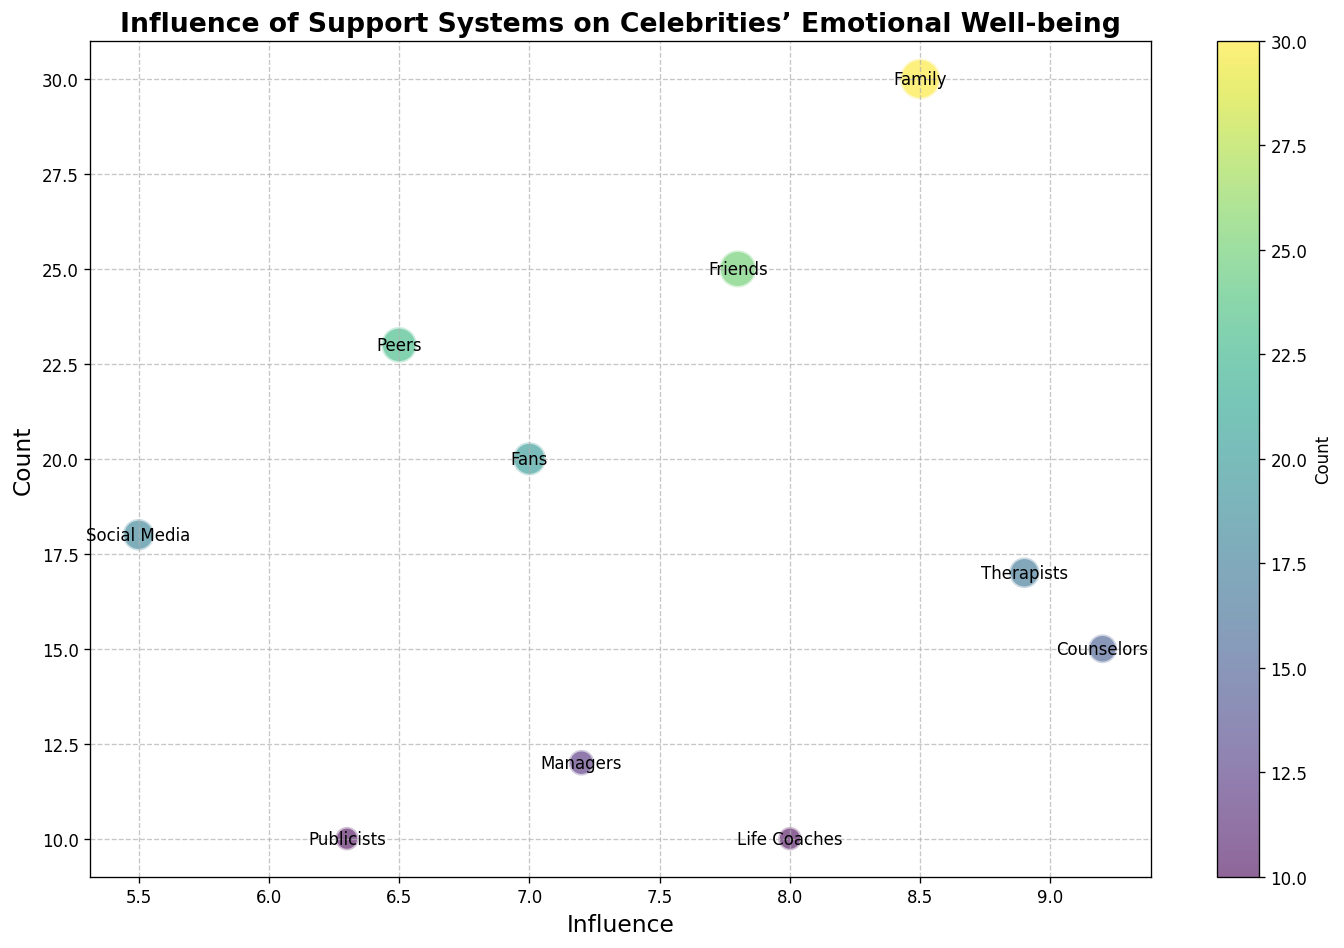Which support system has the highest count and how does its influence compare to other systems? First, identify the support system with the highest count; this is "Family" with a count of 30. Then, check the influence of "Family," which is 8.5. Compare this to other influences to see how it ranks.
Answer: Family has the highest count; its influence of 8.5 is relatively high compared to others Which support system is attributed with the highest influence, and how many individuals are involved in this support system? Determine the highest influence value, which is 9.2, and find the corresponding support system, which is "Counselors." Check the count for "Counselors," which is 15.
Answer: Counselors; 15 individuals Compare the counts of "Fans" and "Therapists." Which is higher and by how much? Check the count for "Fans," which is 20, and the count for "Therapists," which is 17. Subtract to find the difference.
Answer: Fans have a higher count by 3 What is the average influence of "Family" and "Friends"? Find the influence values for "Family" (8.5) and "Friends" (7.8). Calculate the average: (8.5 + 7.8) / 2.
Answer: 8.15 Which support system has the smallest influence and what is its count? Identify the smallest influence value, which is 5.5, and find the corresponding support system, which is "Social Media." Check the count for "Social Media," which is 18.
Answer: Social Media; 18 Compare the counts of "Life Coaches" and "Managers." Are they equal? Check the count for "Life Coaches," which is 10, and the count for "Managers," which is 12. Compare the two counts.
Answer: No, they are not equal; Managers have a count of 12 while Life Coaches have a count of 10 